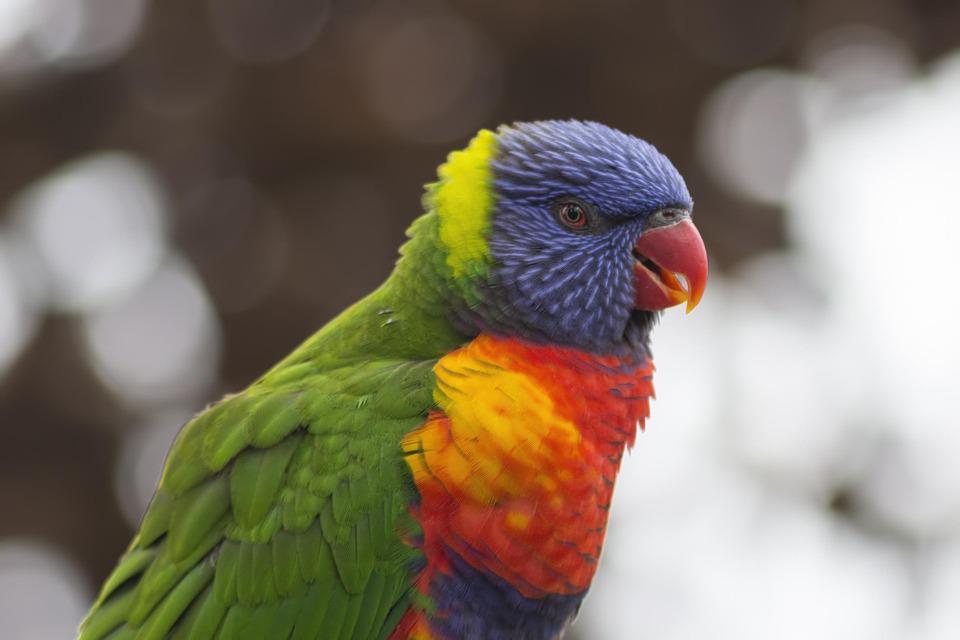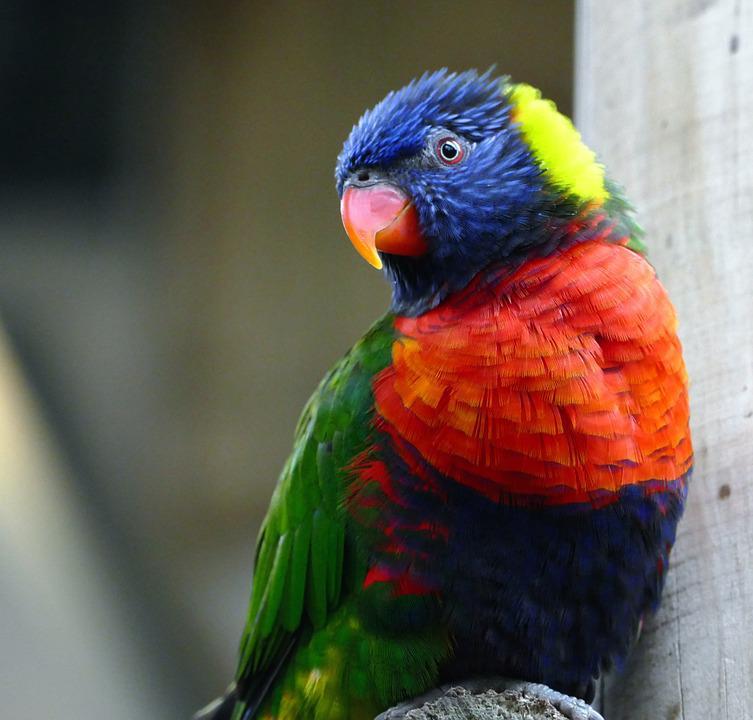The first image is the image on the left, the second image is the image on the right. Analyze the images presented: Is the assertion "More than one bird is visible, even if only partially." valid? Answer yes or no. No. The first image is the image on the left, the second image is the image on the right. Examine the images to the left and right. Is the description "There are exactly two birds in the image on the left." accurate? Answer yes or no. No. 